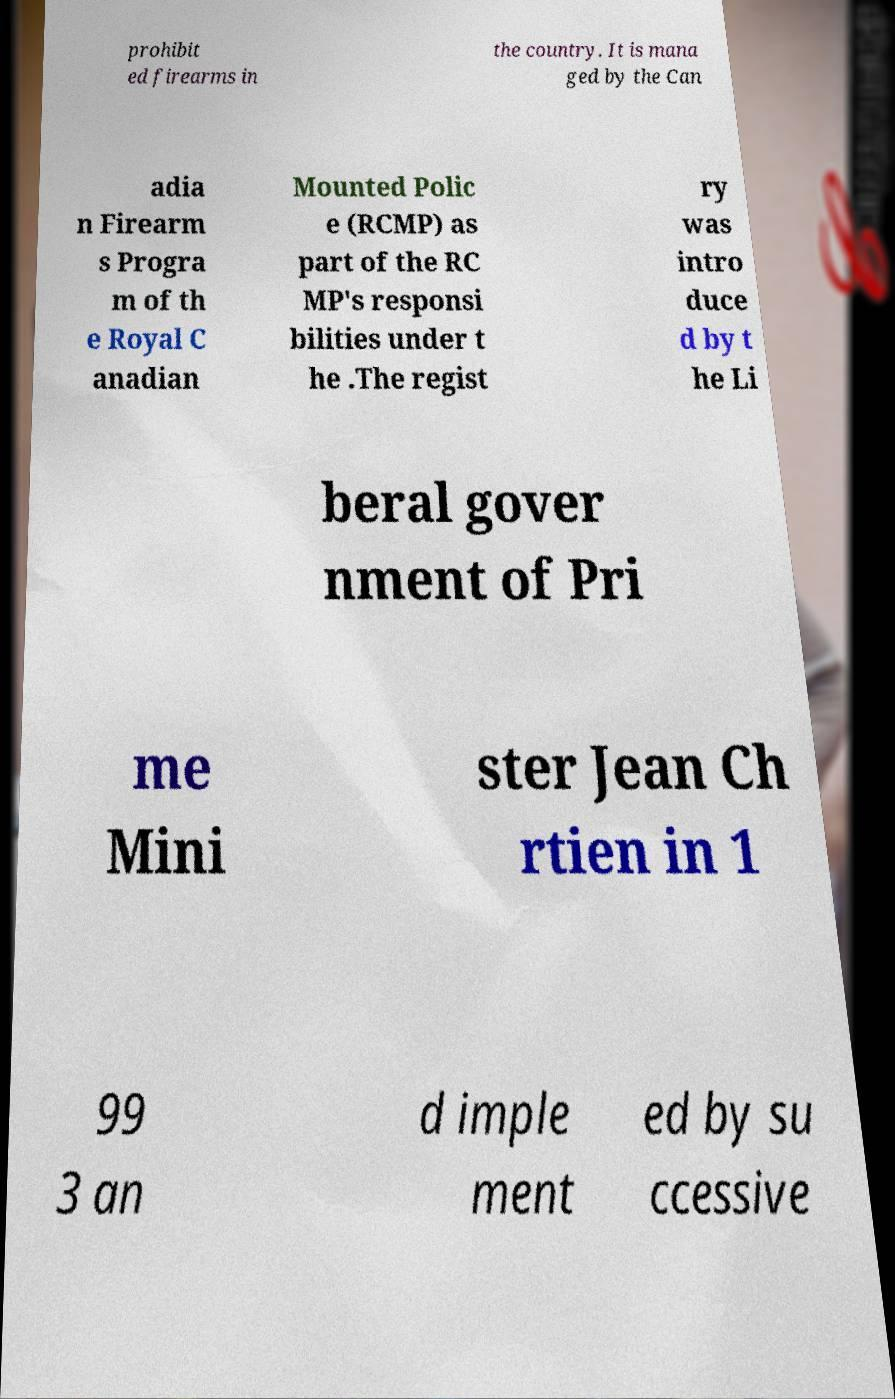Can you accurately transcribe the text from the provided image for me? prohibit ed firearms in the country. It is mana ged by the Can adia n Firearm s Progra m of th e Royal C anadian Mounted Polic e (RCMP) as part of the RC MP's responsi bilities under t he .The regist ry was intro duce d by t he Li beral gover nment of Pri me Mini ster Jean Ch rtien in 1 99 3 an d imple ment ed by su ccessive 